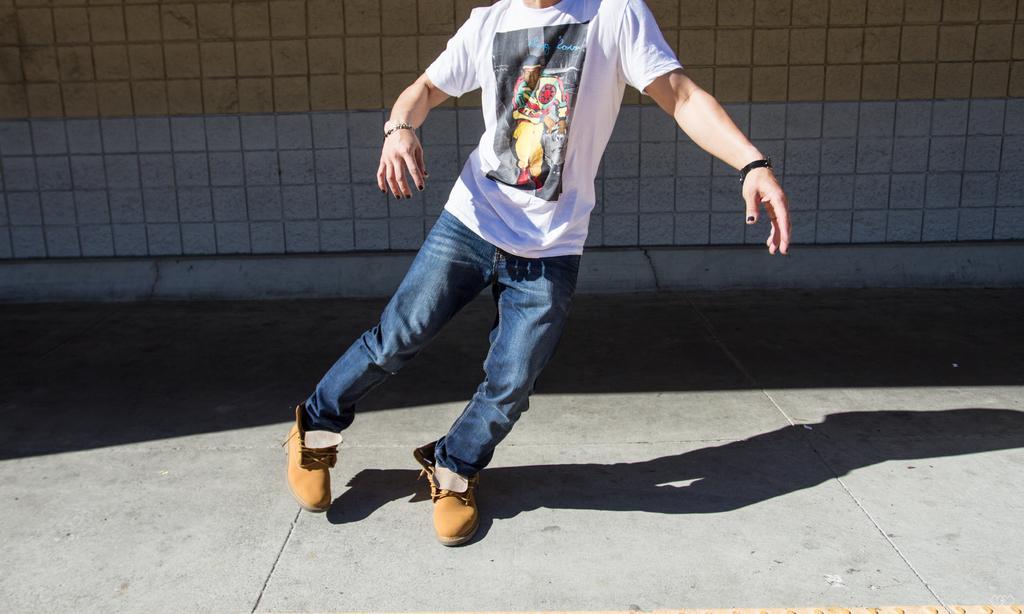In one or two sentences, can you explain what this image depicts? In this picture, it seems like a person in the foreground area of the image and a wall in the background. 